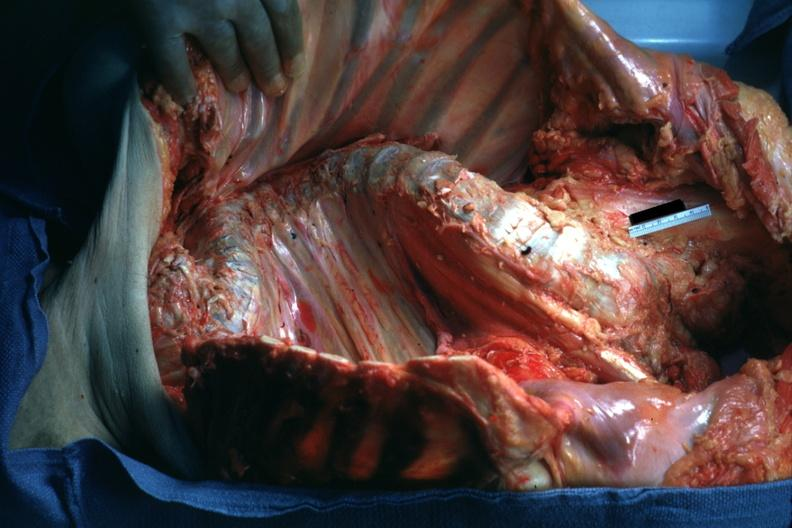does this image show opened body with organs?
Answer the question using a single word or phrase. Yes 